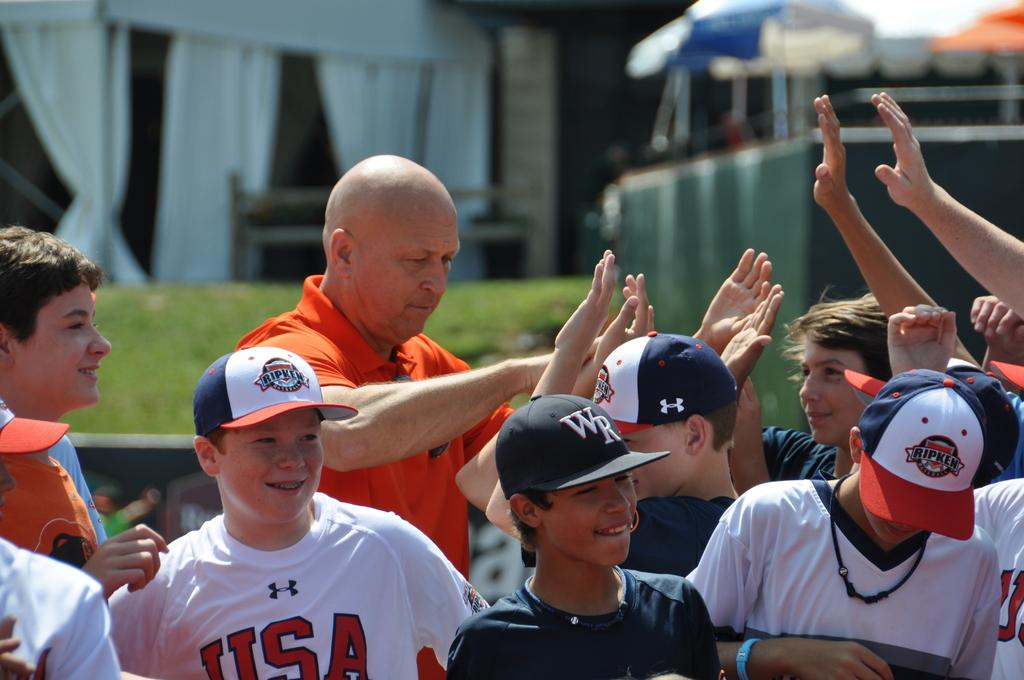<image>
Summarize the visual content of the image. A boy wearing a shirt with USA on it stands among a group of boys wearing baseball hats. 